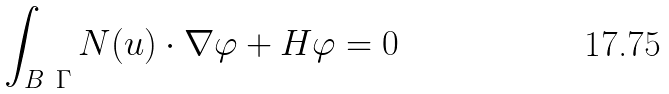<formula> <loc_0><loc_0><loc_500><loc_500>\int _ { B \ \Gamma } N ( u ) \cdot \nabla \varphi + H \varphi = 0</formula> 